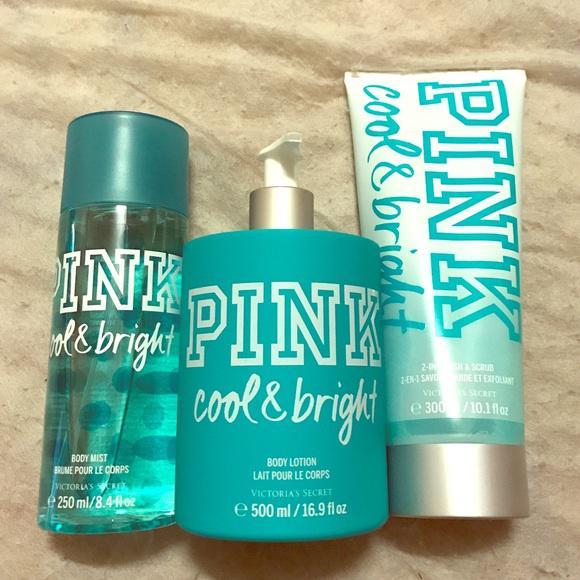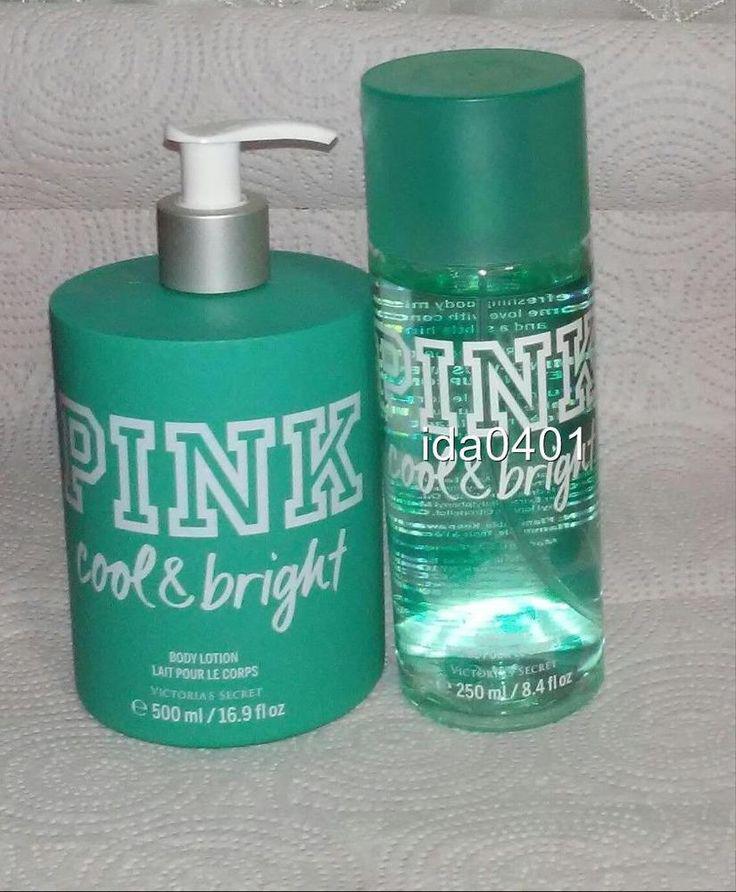The first image is the image on the left, the second image is the image on the right. For the images displayed, is the sentence "A short wide pump bottle of lotion is shown with one other product in one image and with two other products in the other image." factually correct? Answer yes or no. Yes. The first image is the image on the left, the second image is the image on the right. For the images displayed, is the sentence "The left image shows exactly three products, each in a different packaging format." factually correct? Answer yes or no. Yes. 